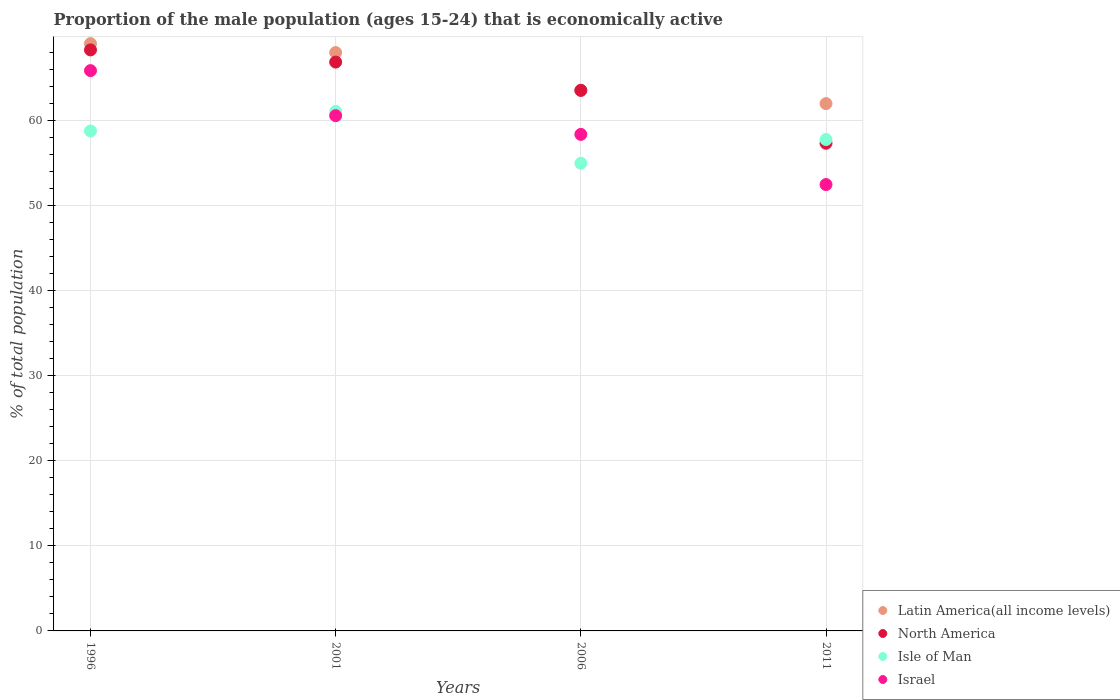How many different coloured dotlines are there?
Your response must be concise. 4. What is the proportion of the male population that is economically active in Israel in 2001?
Your answer should be very brief. 60.6. Across all years, what is the maximum proportion of the male population that is economically active in Israel?
Ensure brevity in your answer.  65.9. In which year was the proportion of the male population that is economically active in North America minimum?
Make the answer very short. 2011. What is the total proportion of the male population that is economically active in Latin America(all income levels) in the graph?
Ensure brevity in your answer.  262.72. What is the difference between the proportion of the male population that is economically active in Israel in 1996 and that in 2001?
Your answer should be compact. 5.3. What is the difference between the proportion of the male population that is economically active in Isle of Man in 2011 and the proportion of the male population that is economically active in Latin America(all income levels) in 1996?
Your answer should be compact. -11.28. What is the average proportion of the male population that is economically active in Latin America(all income levels) per year?
Keep it short and to the point. 65.68. In the year 2001, what is the difference between the proportion of the male population that is economically active in North America and proportion of the male population that is economically active in Latin America(all income levels)?
Provide a succinct answer. -1.12. In how many years, is the proportion of the male population that is economically active in Isle of Man greater than 24 %?
Offer a very short reply. 4. What is the ratio of the proportion of the male population that is economically active in Latin America(all income levels) in 2001 to that in 2006?
Keep it short and to the point. 1.07. What is the difference between the highest and the second highest proportion of the male population that is economically active in North America?
Ensure brevity in your answer.  1.43. What is the difference between the highest and the lowest proportion of the male population that is economically active in Isle of Man?
Make the answer very short. 6.1. Is it the case that in every year, the sum of the proportion of the male population that is economically active in Israel and proportion of the male population that is economically active in Latin America(all income levels)  is greater than the sum of proportion of the male population that is economically active in Isle of Man and proportion of the male population that is economically active in North America?
Your answer should be compact. No. Is it the case that in every year, the sum of the proportion of the male population that is economically active in North America and proportion of the male population that is economically active in Latin America(all income levels)  is greater than the proportion of the male population that is economically active in Israel?
Keep it short and to the point. Yes. Is the proportion of the male population that is economically active in North America strictly greater than the proportion of the male population that is economically active in Isle of Man over the years?
Ensure brevity in your answer.  No. How many dotlines are there?
Provide a succinct answer. 4. How many years are there in the graph?
Provide a succinct answer. 4. What is the difference between two consecutive major ticks on the Y-axis?
Make the answer very short. 10. Are the values on the major ticks of Y-axis written in scientific E-notation?
Offer a very short reply. No. Does the graph contain any zero values?
Offer a terse response. No. Does the graph contain grids?
Give a very brief answer. Yes. Where does the legend appear in the graph?
Keep it short and to the point. Bottom right. How many legend labels are there?
Ensure brevity in your answer.  4. How are the legend labels stacked?
Give a very brief answer. Vertical. What is the title of the graph?
Provide a short and direct response. Proportion of the male population (ages 15-24) that is economically active. What is the label or title of the X-axis?
Provide a succinct answer. Years. What is the label or title of the Y-axis?
Make the answer very short. % of total population. What is the % of total population in Latin America(all income levels) in 1996?
Give a very brief answer. 69.08. What is the % of total population of North America in 1996?
Give a very brief answer. 68.34. What is the % of total population in Isle of Man in 1996?
Offer a terse response. 58.8. What is the % of total population in Israel in 1996?
Ensure brevity in your answer.  65.9. What is the % of total population of Latin America(all income levels) in 2001?
Provide a short and direct response. 68.03. What is the % of total population in North America in 2001?
Your answer should be compact. 66.9. What is the % of total population of Isle of Man in 2001?
Provide a succinct answer. 61.1. What is the % of total population in Israel in 2001?
Ensure brevity in your answer.  60.6. What is the % of total population of Latin America(all income levels) in 2006?
Give a very brief answer. 63.6. What is the % of total population of North America in 2006?
Offer a very short reply. 63.57. What is the % of total population in Israel in 2006?
Offer a terse response. 58.4. What is the % of total population of Latin America(all income levels) in 2011?
Your answer should be compact. 62.02. What is the % of total population in North America in 2011?
Your answer should be compact. 57.36. What is the % of total population of Isle of Man in 2011?
Your answer should be compact. 57.8. What is the % of total population of Israel in 2011?
Your answer should be very brief. 52.5. Across all years, what is the maximum % of total population in Latin America(all income levels)?
Your response must be concise. 69.08. Across all years, what is the maximum % of total population in North America?
Provide a short and direct response. 68.34. Across all years, what is the maximum % of total population of Isle of Man?
Provide a short and direct response. 61.1. Across all years, what is the maximum % of total population of Israel?
Keep it short and to the point. 65.9. Across all years, what is the minimum % of total population of Latin America(all income levels)?
Your response must be concise. 62.02. Across all years, what is the minimum % of total population of North America?
Your answer should be compact. 57.36. Across all years, what is the minimum % of total population in Israel?
Give a very brief answer. 52.5. What is the total % of total population in Latin America(all income levels) in the graph?
Offer a very short reply. 262.72. What is the total % of total population in North America in the graph?
Your response must be concise. 256.17. What is the total % of total population in Isle of Man in the graph?
Make the answer very short. 232.7. What is the total % of total population of Israel in the graph?
Offer a very short reply. 237.4. What is the difference between the % of total population in Latin America(all income levels) in 1996 and that in 2001?
Make the answer very short. 1.05. What is the difference between the % of total population of North America in 1996 and that in 2001?
Provide a short and direct response. 1.43. What is the difference between the % of total population in Isle of Man in 1996 and that in 2001?
Make the answer very short. -2.3. What is the difference between the % of total population of Israel in 1996 and that in 2001?
Keep it short and to the point. 5.3. What is the difference between the % of total population in Latin America(all income levels) in 1996 and that in 2006?
Your response must be concise. 5.48. What is the difference between the % of total population in North America in 1996 and that in 2006?
Provide a succinct answer. 4.76. What is the difference between the % of total population of Isle of Man in 1996 and that in 2006?
Your response must be concise. 3.8. What is the difference between the % of total population in Latin America(all income levels) in 1996 and that in 2011?
Ensure brevity in your answer.  7.06. What is the difference between the % of total population in North America in 1996 and that in 2011?
Offer a very short reply. 10.98. What is the difference between the % of total population of Isle of Man in 1996 and that in 2011?
Make the answer very short. 1. What is the difference between the % of total population of Latin America(all income levels) in 2001 and that in 2006?
Give a very brief answer. 4.43. What is the difference between the % of total population of North America in 2001 and that in 2006?
Keep it short and to the point. 3.33. What is the difference between the % of total population of Isle of Man in 2001 and that in 2006?
Provide a succinct answer. 6.1. What is the difference between the % of total population of Latin America(all income levels) in 2001 and that in 2011?
Your answer should be compact. 6. What is the difference between the % of total population in North America in 2001 and that in 2011?
Your answer should be compact. 9.55. What is the difference between the % of total population of Isle of Man in 2001 and that in 2011?
Ensure brevity in your answer.  3.3. What is the difference between the % of total population in Israel in 2001 and that in 2011?
Provide a succinct answer. 8.1. What is the difference between the % of total population in Latin America(all income levels) in 2006 and that in 2011?
Your answer should be compact. 1.58. What is the difference between the % of total population of North America in 2006 and that in 2011?
Keep it short and to the point. 6.22. What is the difference between the % of total population of Latin America(all income levels) in 1996 and the % of total population of North America in 2001?
Give a very brief answer. 2.17. What is the difference between the % of total population of Latin America(all income levels) in 1996 and the % of total population of Isle of Man in 2001?
Keep it short and to the point. 7.98. What is the difference between the % of total population in Latin America(all income levels) in 1996 and the % of total population in Israel in 2001?
Your response must be concise. 8.48. What is the difference between the % of total population of North America in 1996 and the % of total population of Isle of Man in 2001?
Ensure brevity in your answer.  7.24. What is the difference between the % of total population in North America in 1996 and the % of total population in Israel in 2001?
Your answer should be very brief. 7.74. What is the difference between the % of total population in Isle of Man in 1996 and the % of total population in Israel in 2001?
Provide a succinct answer. -1.8. What is the difference between the % of total population of Latin America(all income levels) in 1996 and the % of total population of North America in 2006?
Keep it short and to the point. 5.5. What is the difference between the % of total population in Latin America(all income levels) in 1996 and the % of total population in Isle of Man in 2006?
Your response must be concise. 14.08. What is the difference between the % of total population in Latin America(all income levels) in 1996 and the % of total population in Israel in 2006?
Your answer should be very brief. 10.68. What is the difference between the % of total population of North America in 1996 and the % of total population of Isle of Man in 2006?
Offer a terse response. 13.34. What is the difference between the % of total population in North America in 1996 and the % of total population in Israel in 2006?
Make the answer very short. 9.94. What is the difference between the % of total population in Latin America(all income levels) in 1996 and the % of total population in North America in 2011?
Ensure brevity in your answer.  11.72. What is the difference between the % of total population of Latin America(all income levels) in 1996 and the % of total population of Isle of Man in 2011?
Keep it short and to the point. 11.28. What is the difference between the % of total population of Latin America(all income levels) in 1996 and the % of total population of Israel in 2011?
Keep it short and to the point. 16.58. What is the difference between the % of total population in North America in 1996 and the % of total population in Isle of Man in 2011?
Offer a terse response. 10.54. What is the difference between the % of total population of North America in 1996 and the % of total population of Israel in 2011?
Your response must be concise. 15.84. What is the difference between the % of total population in Latin America(all income levels) in 2001 and the % of total population in North America in 2006?
Give a very brief answer. 4.45. What is the difference between the % of total population of Latin America(all income levels) in 2001 and the % of total population of Isle of Man in 2006?
Make the answer very short. 13.03. What is the difference between the % of total population in Latin America(all income levels) in 2001 and the % of total population in Israel in 2006?
Offer a very short reply. 9.63. What is the difference between the % of total population of North America in 2001 and the % of total population of Isle of Man in 2006?
Your answer should be very brief. 11.9. What is the difference between the % of total population of North America in 2001 and the % of total population of Israel in 2006?
Your answer should be very brief. 8.51. What is the difference between the % of total population in Isle of Man in 2001 and the % of total population in Israel in 2006?
Give a very brief answer. 2.7. What is the difference between the % of total population of Latin America(all income levels) in 2001 and the % of total population of North America in 2011?
Your answer should be compact. 10.67. What is the difference between the % of total population of Latin America(all income levels) in 2001 and the % of total population of Isle of Man in 2011?
Your response must be concise. 10.23. What is the difference between the % of total population in Latin America(all income levels) in 2001 and the % of total population in Israel in 2011?
Make the answer very short. 15.53. What is the difference between the % of total population in North America in 2001 and the % of total population in Isle of Man in 2011?
Provide a succinct answer. 9.11. What is the difference between the % of total population of North America in 2001 and the % of total population of Israel in 2011?
Your answer should be very brief. 14.4. What is the difference between the % of total population of Latin America(all income levels) in 2006 and the % of total population of North America in 2011?
Offer a very short reply. 6.24. What is the difference between the % of total population in Latin America(all income levels) in 2006 and the % of total population in Isle of Man in 2011?
Provide a succinct answer. 5.8. What is the difference between the % of total population of Latin America(all income levels) in 2006 and the % of total population of Israel in 2011?
Ensure brevity in your answer.  11.1. What is the difference between the % of total population in North America in 2006 and the % of total population in Isle of Man in 2011?
Keep it short and to the point. 5.77. What is the difference between the % of total population in North America in 2006 and the % of total population in Israel in 2011?
Your response must be concise. 11.07. What is the difference between the % of total population in Isle of Man in 2006 and the % of total population in Israel in 2011?
Your answer should be very brief. 2.5. What is the average % of total population of Latin America(all income levels) per year?
Give a very brief answer. 65.68. What is the average % of total population of North America per year?
Give a very brief answer. 64.04. What is the average % of total population in Isle of Man per year?
Your answer should be compact. 58.17. What is the average % of total population in Israel per year?
Your response must be concise. 59.35. In the year 1996, what is the difference between the % of total population in Latin America(all income levels) and % of total population in North America?
Your answer should be compact. 0.74. In the year 1996, what is the difference between the % of total population in Latin America(all income levels) and % of total population in Isle of Man?
Offer a terse response. 10.28. In the year 1996, what is the difference between the % of total population in Latin America(all income levels) and % of total population in Israel?
Your answer should be compact. 3.18. In the year 1996, what is the difference between the % of total population of North America and % of total population of Isle of Man?
Your answer should be very brief. 9.54. In the year 1996, what is the difference between the % of total population in North America and % of total population in Israel?
Make the answer very short. 2.44. In the year 2001, what is the difference between the % of total population of Latin America(all income levels) and % of total population of North America?
Your answer should be compact. 1.12. In the year 2001, what is the difference between the % of total population of Latin America(all income levels) and % of total population of Isle of Man?
Give a very brief answer. 6.93. In the year 2001, what is the difference between the % of total population of Latin America(all income levels) and % of total population of Israel?
Provide a short and direct response. 7.43. In the year 2001, what is the difference between the % of total population of North America and % of total population of Isle of Man?
Your answer should be very brief. 5.8. In the year 2001, what is the difference between the % of total population in North America and % of total population in Israel?
Provide a succinct answer. 6.3. In the year 2001, what is the difference between the % of total population in Isle of Man and % of total population in Israel?
Offer a very short reply. 0.5. In the year 2006, what is the difference between the % of total population in Latin America(all income levels) and % of total population in North America?
Keep it short and to the point. 0.02. In the year 2006, what is the difference between the % of total population of Latin America(all income levels) and % of total population of Isle of Man?
Provide a succinct answer. 8.6. In the year 2006, what is the difference between the % of total population of Latin America(all income levels) and % of total population of Israel?
Your answer should be compact. 5.2. In the year 2006, what is the difference between the % of total population of North America and % of total population of Isle of Man?
Keep it short and to the point. 8.57. In the year 2006, what is the difference between the % of total population of North America and % of total population of Israel?
Offer a terse response. 5.17. In the year 2006, what is the difference between the % of total population in Isle of Man and % of total population in Israel?
Your answer should be compact. -3.4. In the year 2011, what is the difference between the % of total population in Latin America(all income levels) and % of total population in North America?
Ensure brevity in your answer.  4.67. In the year 2011, what is the difference between the % of total population in Latin America(all income levels) and % of total population in Isle of Man?
Ensure brevity in your answer.  4.22. In the year 2011, what is the difference between the % of total population in Latin America(all income levels) and % of total population in Israel?
Offer a very short reply. 9.52. In the year 2011, what is the difference between the % of total population of North America and % of total population of Isle of Man?
Your answer should be compact. -0.44. In the year 2011, what is the difference between the % of total population in North America and % of total population in Israel?
Provide a succinct answer. 4.86. What is the ratio of the % of total population in Latin America(all income levels) in 1996 to that in 2001?
Offer a terse response. 1.02. What is the ratio of the % of total population of North America in 1996 to that in 2001?
Offer a terse response. 1.02. What is the ratio of the % of total population in Isle of Man in 1996 to that in 2001?
Your answer should be very brief. 0.96. What is the ratio of the % of total population of Israel in 1996 to that in 2001?
Provide a succinct answer. 1.09. What is the ratio of the % of total population in Latin America(all income levels) in 1996 to that in 2006?
Ensure brevity in your answer.  1.09. What is the ratio of the % of total population in North America in 1996 to that in 2006?
Offer a very short reply. 1.07. What is the ratio of the % of total population in Isle of Man in 1996 to that in 2006?
Offer a terse response. 1.07. What is the ratio of the % of total population of Israel in 1996 to that in 2006?
Your response must be concise. 1.13. What is the ratio of the % of total population of Latin America(all income levels) in 1996 to that in 2011?
Offer a terse response. 1.11. What is the ratio of the % of total population in North America in 1996 to that in 2011?
Make the answer very short. 1.19. What is the ratio of the % of total population of Isle of Man in 1996 to that in 2011?
Offer a very short reply. 1.02. What is the ratio of the % of total population in Israel in 1996 to that in 2011?
Ensure brevity in your answer.  1.26. What is the ratio of the % of total population in Latin America(all income levels) in 2001 to that in 2006?
Your answer should be compact. 1.07. What is the ratio of the % of total population of North America in 2001 to that in 2006?
Make the answer very short. 1.05. What is the ratio of the % of total population of Isle of Man in 2001 to that in 2006?
Your response must be concise. 1.11. What is the ratio of the % of total population in Israel in 2001 to that in 2006?
Make the answer very short. 1.04. What is the ratio of the % of total population of Latin America(all income levels) in 2001 to that in 2011?
Provide a succinct answer. 1.1. What is the ratio of the % of total population in North America in 2001 to that in 2011?
Make the answer very short. 1.17. What is the ratio of the % of total population in Isle of Man in 2001 to that in 2011?
Your answer should be compact. 1.06. What is the ratio of the % of total population of Israel in 2001 to that in 2011?
Your answer should be compact. 1.15. What is the ratio of the % of total population in Latin America(all income levels) in 2006 to that in 2011?
Keep it short and to the point. 1.03. What is the ratio of the % of total population in North America in 2006 to that in 2011?
Ensure brevity in your answer.  1.11. What is the ratio of the % of total population of Isle of Man in 2006 to that in 2011?
Offer a terse response. 0.95. What is the ratio of the % of total population of Israel in 2006 to that in 2011?
Offer a very short reply. 1.11. What is the difference between the highest and the second highest % of total population of Latin America(all income levels)?
Your response must be concise. 1.05. What is the difference between the highest and the second highest % of total population in North America?
Your answer should be compact. 1.43. What is the difference between the highest and the second highest % of total population in Israel?
Make the answer very short. 5.3. What is the difference between the highest and the lowest % of total population of Latin America(all income levels)?
Offer a terse response. 7.06. What is the difference between the highest and the lowest % of total population in North America?
Offer a very short reply. 10.98. What is the difference between the highest and the lowest % of total population of Israel?
Provide a short and direct response. 13.4. 